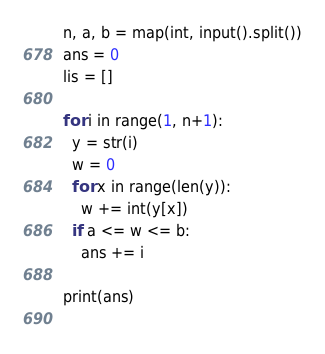Convert code to text. <code><loc_0><loc_0><loc_500><loc_500><_Python_>n, a, b = map(int, input().split())
ans = 0
lis = []

for i in range(1, n+1):
  y = str(i)
  w = 0
  for x in range(len(y)):
    w += int(y[x])
  if a <= w <= b:
    ans += i

print(ans)
    
</code> 